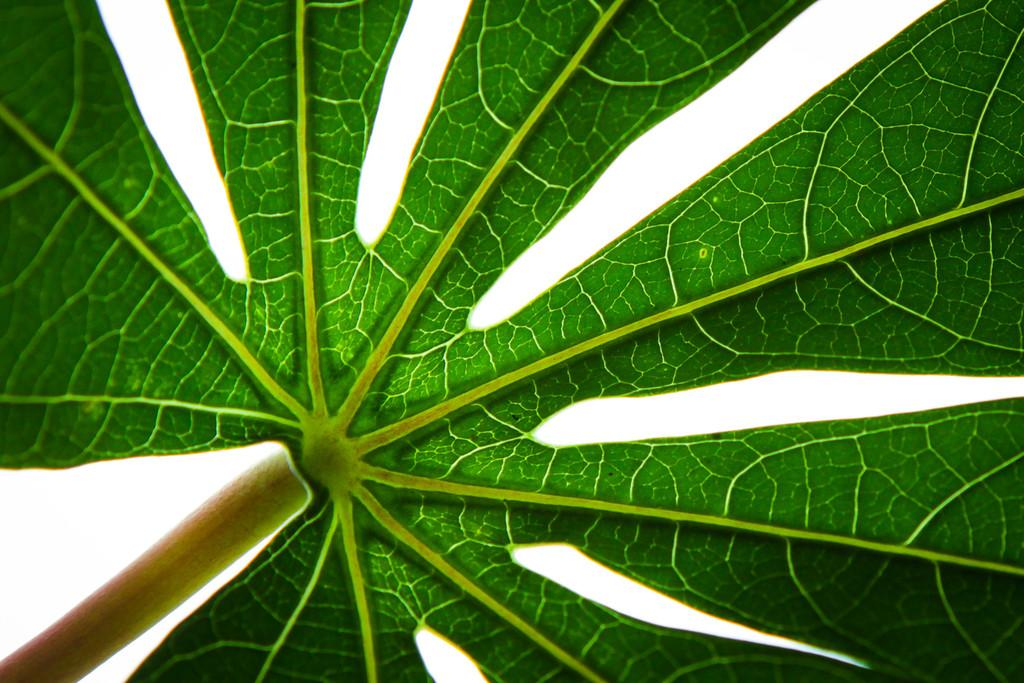What is the main subject of the image? The main subject of the image is a leaf. What level of learning does the beginner cow demonstrate in the image? There is no cow present in the image, and therefore no learning or level of learning can be observed. 